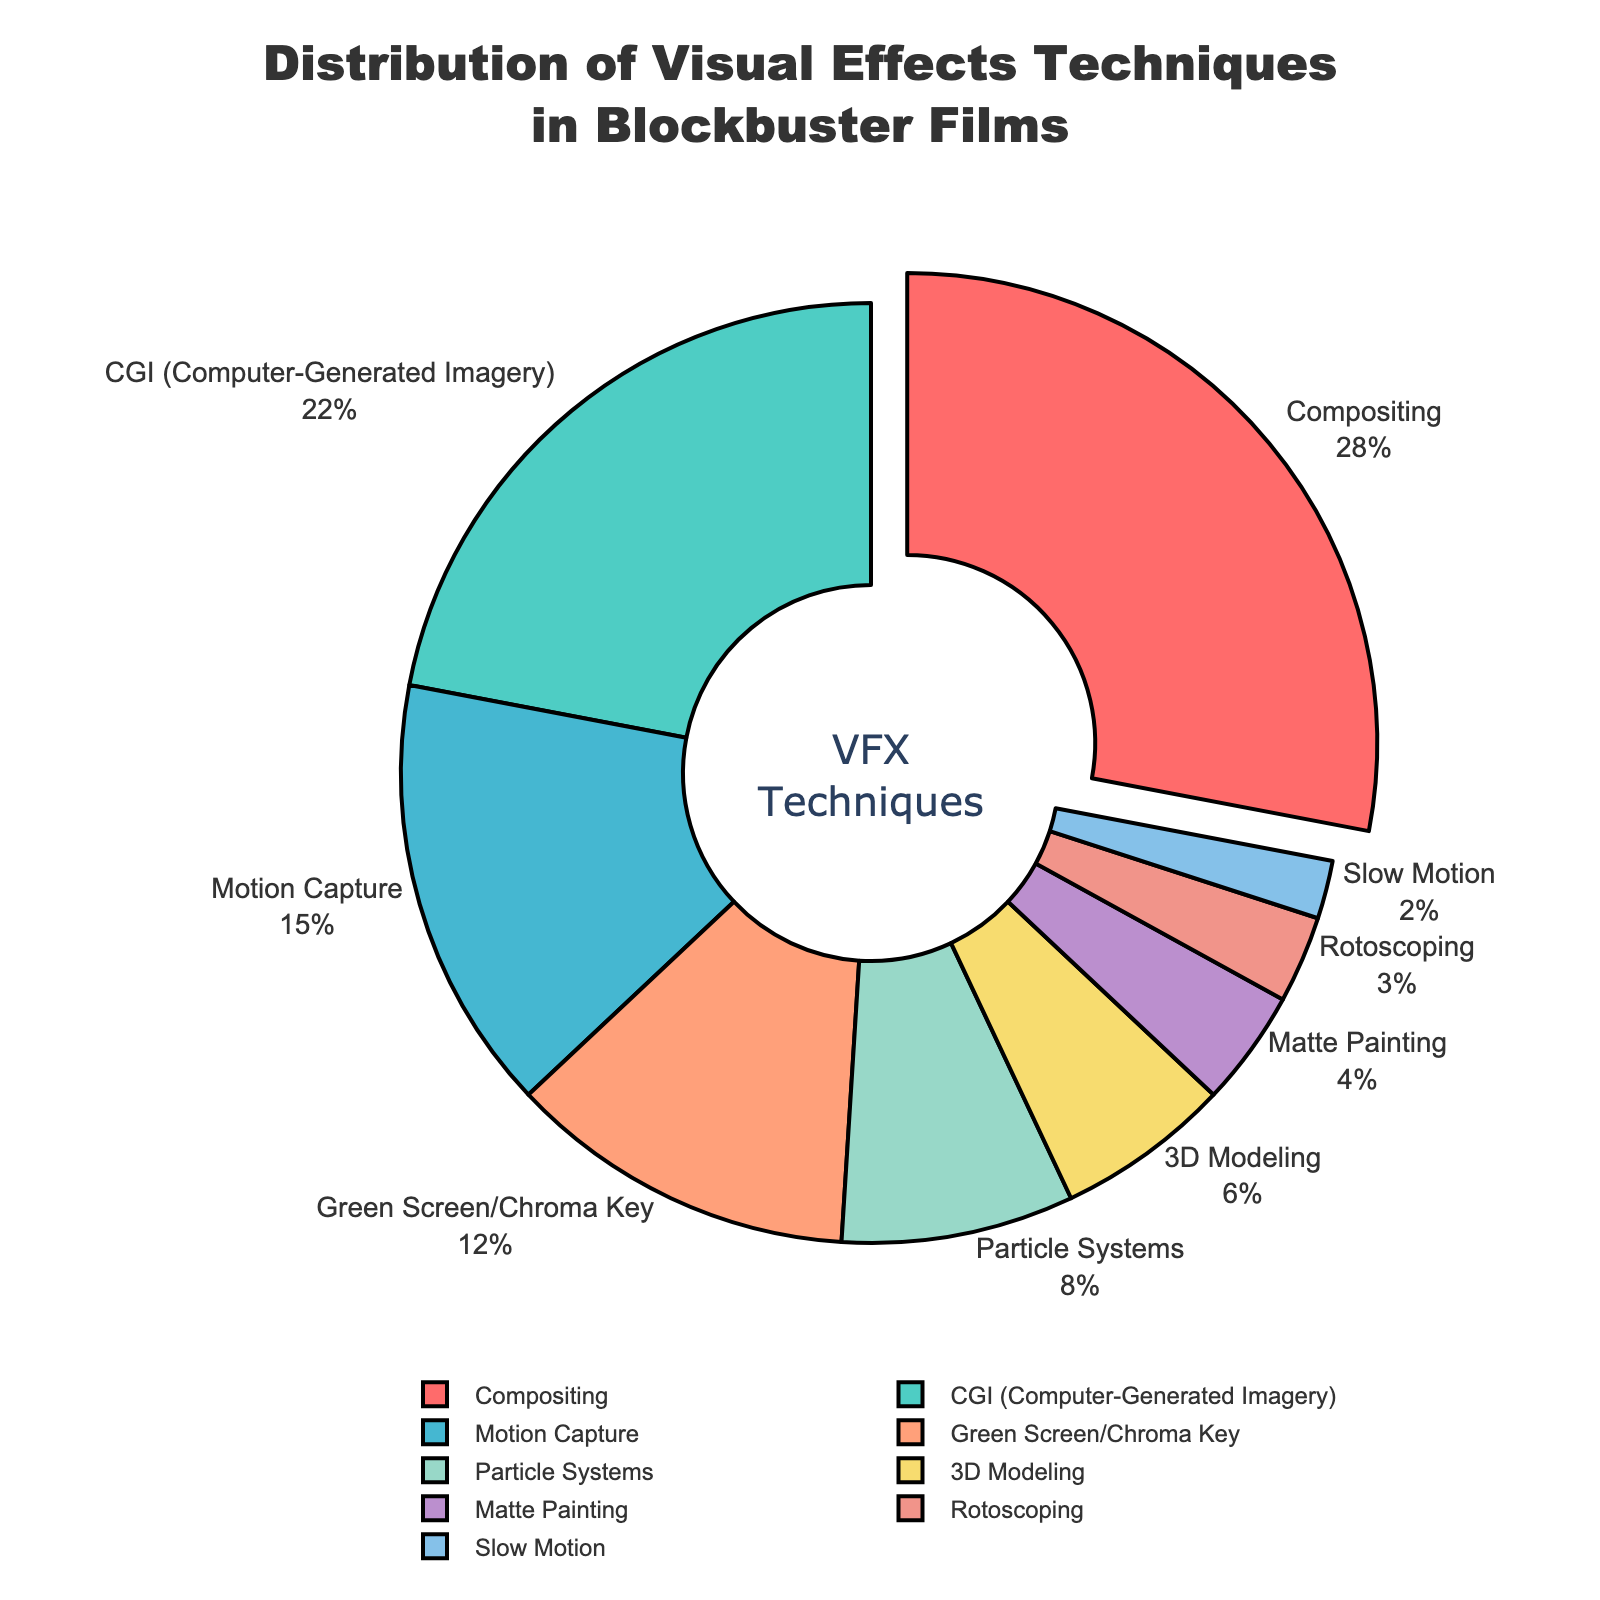What is the most commonly used visual effects technique in blockbuster films? The figure shows a pie chart with different visual effects techniques. The largest segment is labeled "Compositing" with a percentage of 28.
Answer: Compositing How much more popular is Compositing compared to CGI? The figure shows that Compositing accounts for 28% and CGI accounts for 22%. Subtract 22 from 28 to find the difference.
Answer: 6% What is the combined percentage of Motion Capture, Green Screen/Chroma Key, and Particle Systems techniques? Add the percentages of Motion Capture (15%), Green Screen/Chroma Key (12%), and Particle Systems (8%). 15 + 12 + 8 = 35.
Answer: 35% Which visual technique has the smallest percentage, and what is it? The smallest segment in the pie chart is labeled "Slow Motion" with a percentage of 2.
Answer: Slow Motion, 2% How does the popularity of 3D Modeling compare to Matte Painting in terms of percentage? The figure shows that 3D Modeling has a percentage of 6%, while Matte Painting has a percentage of 4%. Compare 6% and 4%.
Answer: 3D Modeling is 2% more popular than Matte Painting Which techniques together make up nearly half of the visual effects techniques used? The figure shows: Compositing 28%, CGI 22%. Adding these together: 28 + 22 = 50.
Answer: Compositing and CGI If you sum the percentages of the least used three techniques, what do you get? The least used three techniques are Matte Painting (4%), Rotoscoping (3%), and Slow Motion (2%). Add these percentages: 4 + 3 + 2 = 9.
Answer: 9% What visual technique has a similar percentage usage as Particle Systems, and by how much do they differ? The figure shows Particle Systems at 8% and Green Screen/Chroma Key at 12%. The difference is 12 - 8 = 4.
Answer: Green Screen/Chroma Key, 4% Which segment is highlighted or "pulled out" in the pie chart? The figure indicates a segment that is visually separated from the rest. The explanation states this segment is Compositing.
Answer: Compositing What percentage of techniques is used by Green Screen/Chroma Key and Rotoscoping combined? Add the percentages for Green Screen/Chroma Key (12%) and Rotoscoping (3%). 12 + 3 = 15.
Answer: 15% 